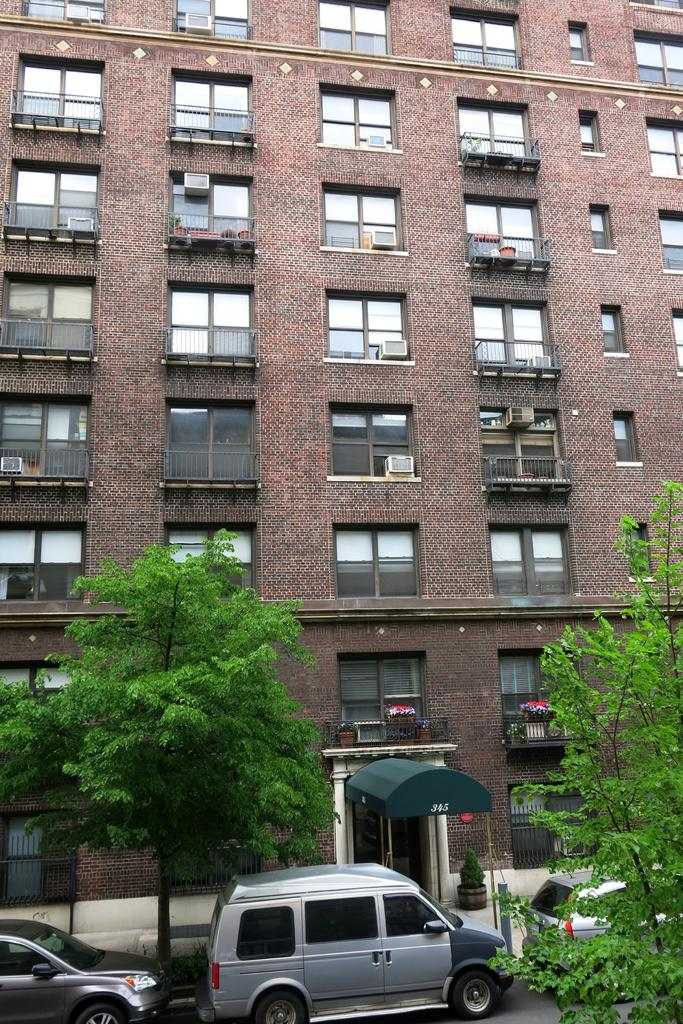What type of structure is visible in the image? There is a building in the image. What natural elements can be seen in the image? There are trees in the image. What man-made objects are present in the image? There are vehicles and a tent in the image. What is the surface on which the building and other objects are placed? The ground is visible in the image. Are there any plants visible in the image? Yes, there is a plant in a pot in the image. What thought is being expressed by the fork in the image? There is no fork present in the image, so it cannot express any thoughts. Can you read the letter that is being delivered by the plant in the image? There is no letter or plant delivering a letter in the image. 